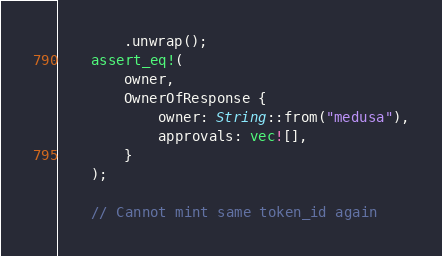<code> <loc_0><loc_0><loc_500><loc_500><_Rust_>        .unwrap();
    assert_eq!(
        owner,
        OwnerOfResponse {
            owner: String::from("medusa"),
            approvals: vec![],
        }
    );

    // Cannot mint same token_id again</code> 